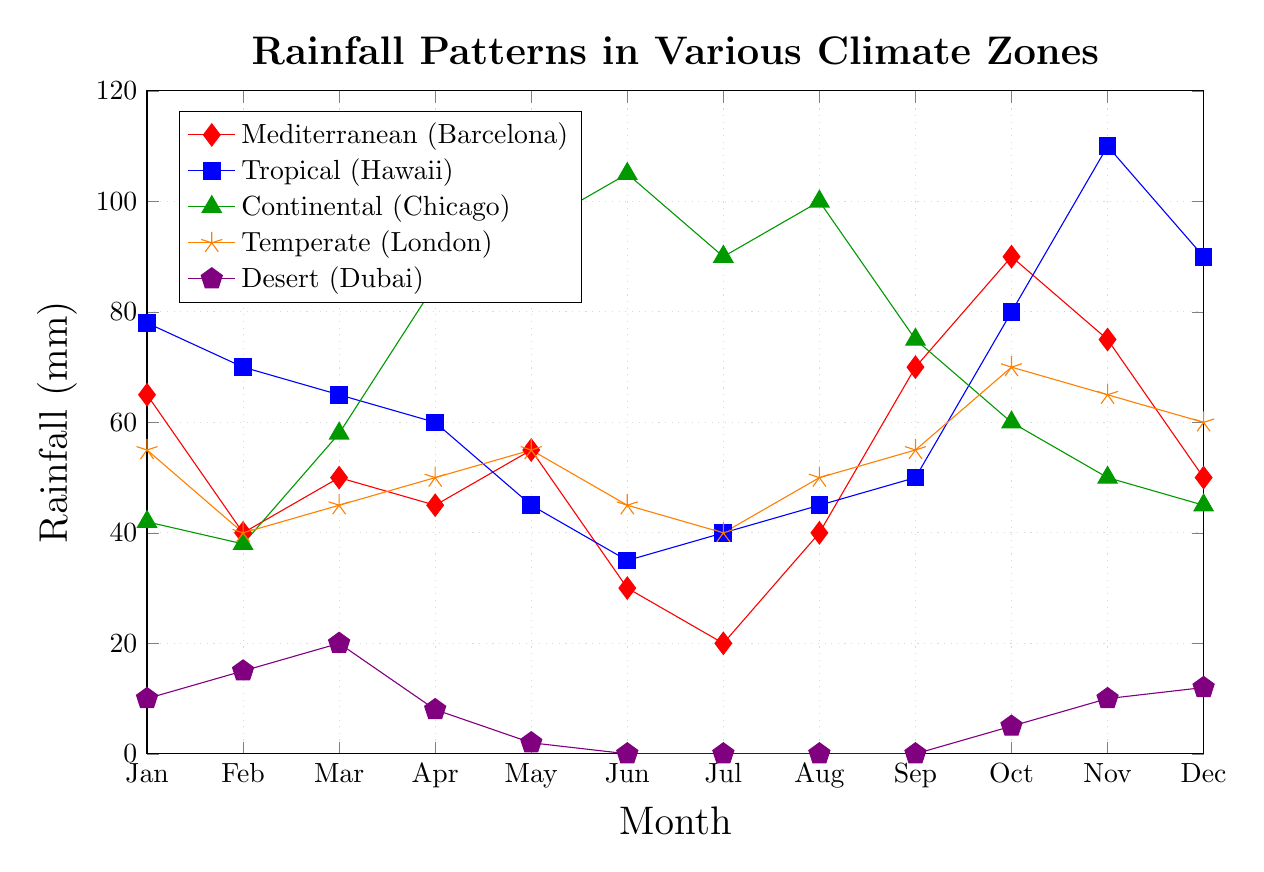What's the highest rainfall in the Continental (Chicago) climate zone, and which month does it occur? The plot shows the rainfall patterns for different months in various climate zones. For the Continental (Chicago) climate zone, find the highest point on the green line and see in which month it occurs, which is June with 105 mm.
Answer: June, 105 mm During which month does the Mediterranean (Barcelona) climate zone receive the least rainfall, and what is the amount? In the plot, the Mediterranean (Barcelona) climate zone line is red. The lowest point occurs in July with 20 mm of rainfall.
Answer: July, 20 mm Compare the rainfall in Tropical (Hawaii) and Desert (Dubai) in November. Which climate zone receives more rainfall, and by how much? In November, the Tropical (Hawaii) point is at 110 mm, and the Desert (Dubai) point is at 10 mm. The difference is 100 mm.
Answer: Tropical (Hawaii) by 100 mm What's the average rainfall across all months for the Temperate (London) zone? First, sum the rainfall values for each month for the Temperate (London) zone, which are 55 + 40 + 45 + 50 + 55 + 45 + 40 + 50 + 55 + 70 + 65 + 60 = 630. Then, divide by the number of months, 630/12 = 52.5.
Answer: 52.5 mm Identify which climate zones have zero rainfall during any given month. List the zones and the months with zero rainfall. From the plot, observe the points at the bottom (y = 0). The Desert (Dubai) climate zone has 0 mm rainfall from June to September.
Answer: Desert (Dubai): June, July, August, September How does the rainfall in the Temperate (London) climate zone change from January to October? Observe the blue line from January (55 mm) to October (70 mm). The rainfall gradually increases from 55 mm to 70 mm.
Answer: Increases from 55 mm to 70 mm Which climate zone experiences the least change in rainfall throughout the year? Compare the range (maximum - minimum) for each zone's rainfall plot. The Desert (Dubai) zone, with a range from 0 to 20 mm, has the least change.
Answer: Desert (Dubai) During which month and in which climate zone does the rainfall exactly match 40 mm? Look at the plot for points at 40 mm. February in the Mediterranean (Barcelona) and January & February in Temperate (London) reach 40 mm.
Answer: Mediterranean (Barcelona), February and Temperate (London), January and February Calculate the total annual rainfall for the Climate zone Desert (Dubai). Sum the monthly rainfall values for Desert (Dubai): 10 + 15 + 20 + 8 + 2 + 0 + 0 + 0 + 0 + 5 + 10 + 12 = 82 mm
Answer: 82 mm 